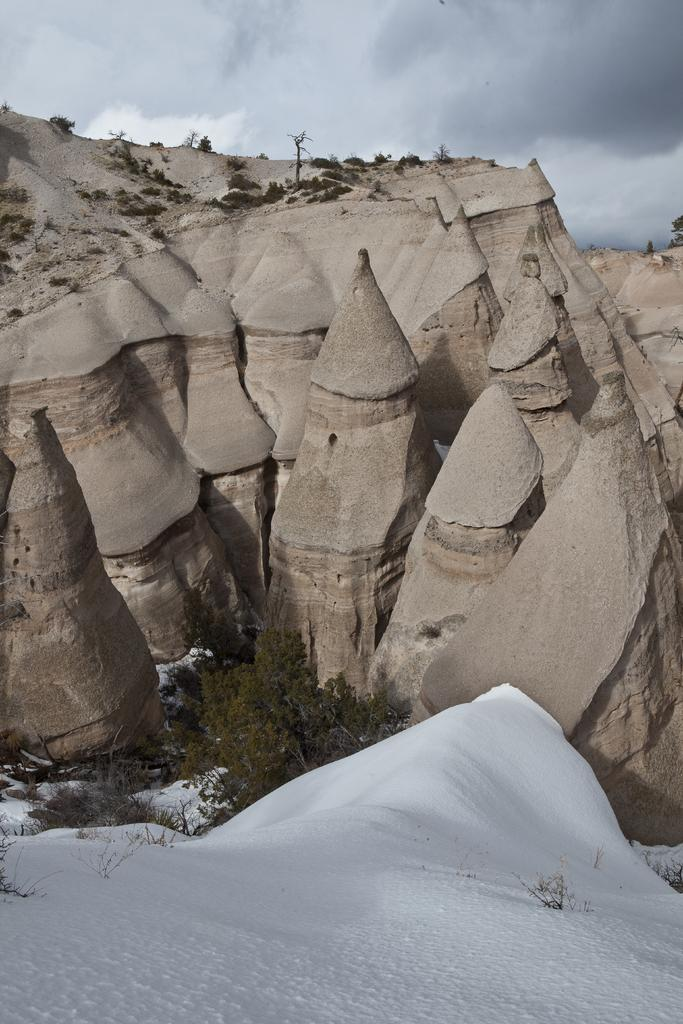What is the predominant weather condition in the image? There is snow in the image, indicating a cold and wintry condition. What type of natural elements can be seen in the image? There are trees and rocks visible in the image. How would you describe the sky in the image? The sky is cloudy in the image. Can you see any signs of a carpenter working in the image? There is no indication of a carpenter or any carpentry work in the image. What part of the human body can be seen in the image? There are no human body parts visible in the image. 